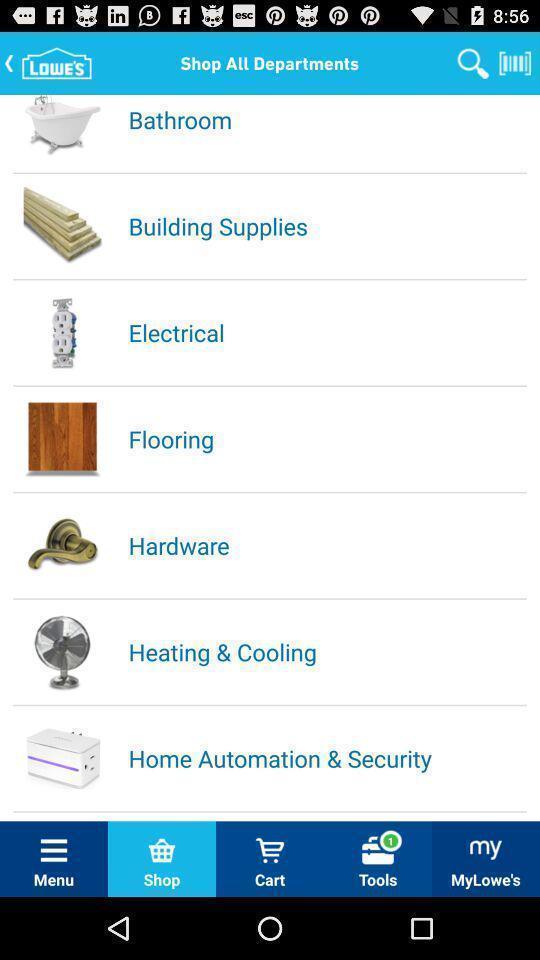What can you discern from this picture? Screen shows all departments of house needs. 